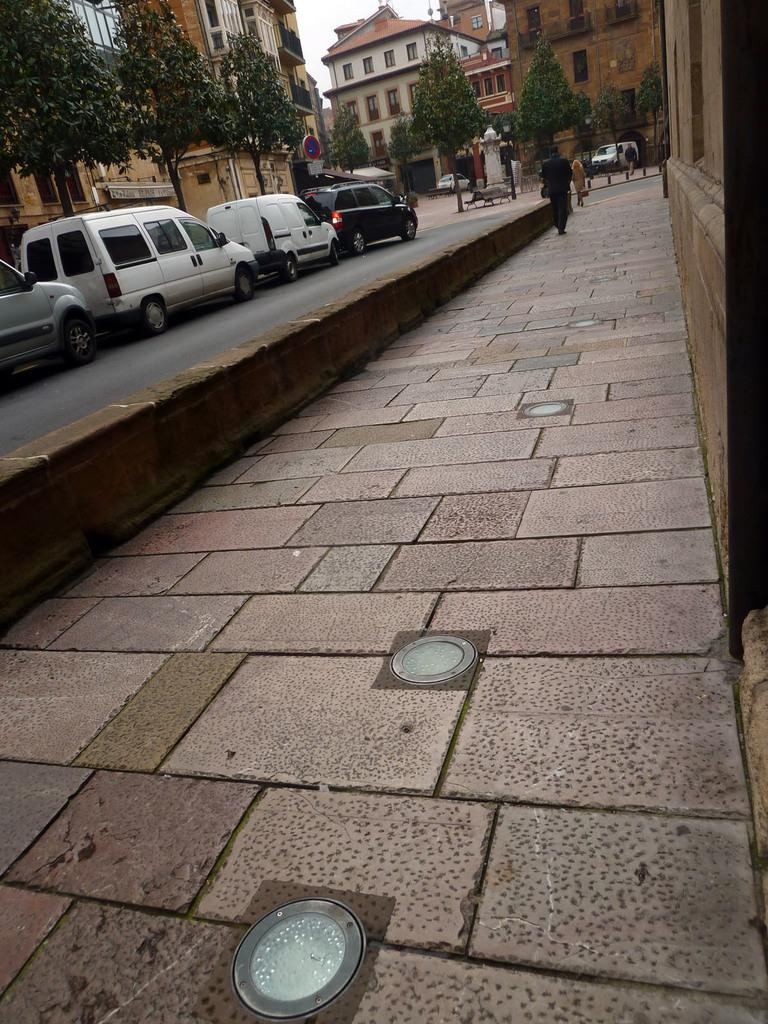What can be seen on the road in the image? There are vehicles parked on the road in the image. Where is the person located in the image? A person is on the walkway in the image. What is visible in the background of the image? There are houses, trees, poles, vehicles, and the sky visible in the background of the image. What type of punishment is being administered to the frog in the image? There is no frog present in the image, and therefore no punishment is being administered. Can you tell me how many skateboards are visible in the image? There is no mention of skateboards in the image, so it cannot be determined how many are visible. 